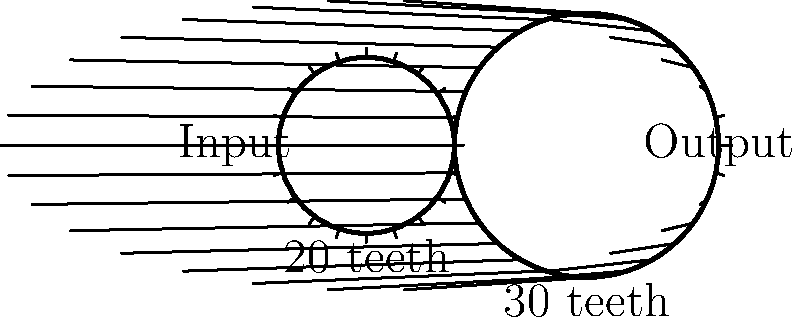As an artist interested in mechanical movements for kinetic sculptures, you're exploring gear systems. In the simple gear train shown, the input gear has 20 teeth and the output gear has 30 teeth. If the input torque is 50 Nm, what is the output torque, assuming no energy loss in the system? To solve this problem, we'll follow these steps:

1. Calculate the gear ratio:
   The gear ratio is the ratio of the number of teeth on the output gear to the number of teeth on the input gear.
   Gear ratio = $\frac{\text{Number of teeth on output gear}}{\text{Number of teeth on input gear}} = \frac{30}{20} = 1.5$

2. Understand the relationship between gear ratio and torque:
   In an ideal gear system with no energy loss, the product of torque and angular velocity is constant. This means that as the gear ratio increases, the output torque increases proportionally.

3. Calculate the output torque:
   Output torque = Input torque × Gear ratio
   $T_{out} = T_{in} \times \frac{N_{out}}{N_{in}}$
   Where $T$ is torque and $N$ is number of teeth.

   $T_{out} = 50 \text{ Nm} \times \frac{30}{20} = 50 \text{ Nm} \times 1.5 = 75 \text{ Nm}$

Therefore, the output torque is 75 Nm.
Answer: 75 Nm 